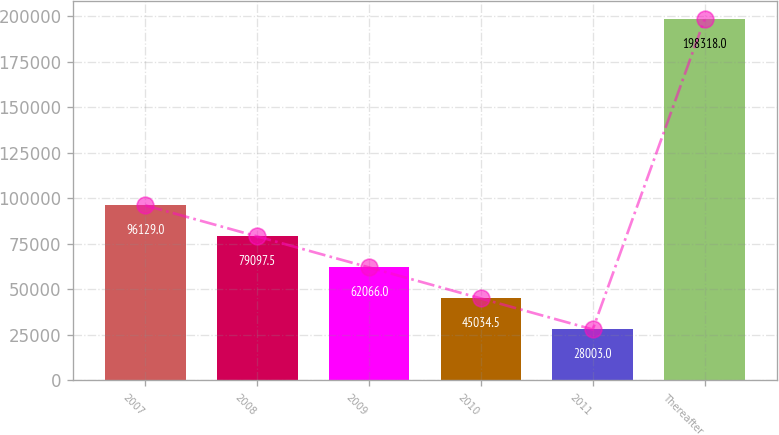Convert chart. <chart><loc_0><loc_0><loc_500><loc_500><bar_chart><fcel>2007<fcel>2008<fcel>2009<fcel>2010<fcel>2011<fcel>Thereafter<nl><fcel>96129<fcel>79097.5<fcel>62066<fcel>45034.5<fcel>28003<fcel>198318<nl></chart> 